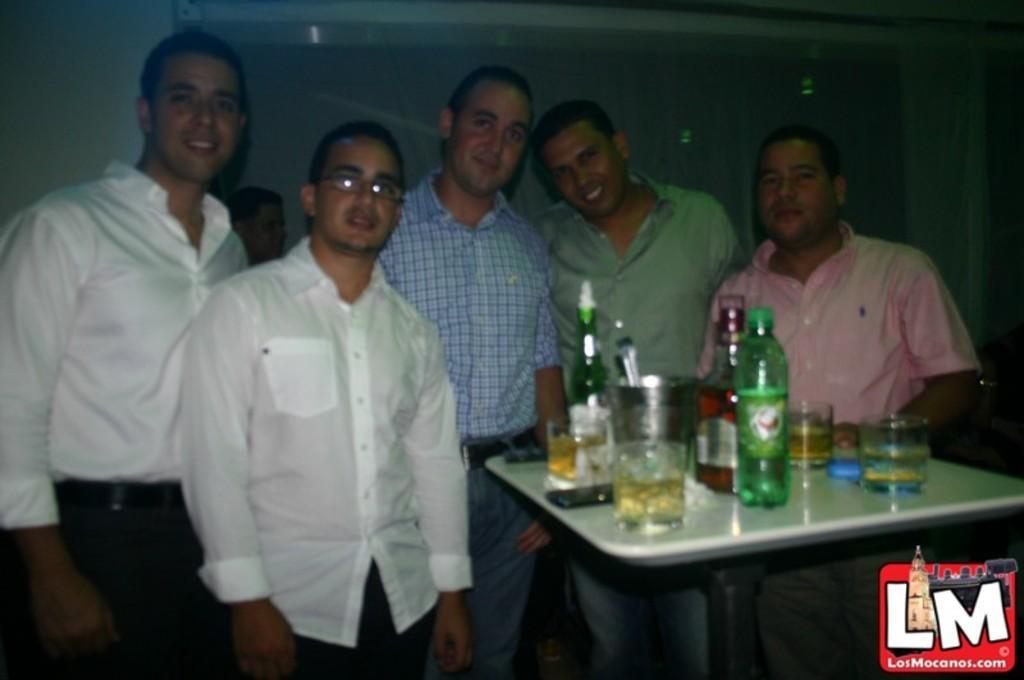How would you summarize this image in a sentence or two? In this image there are group of persons standing and in front of them there are bottles and glasses which are placed on table. 